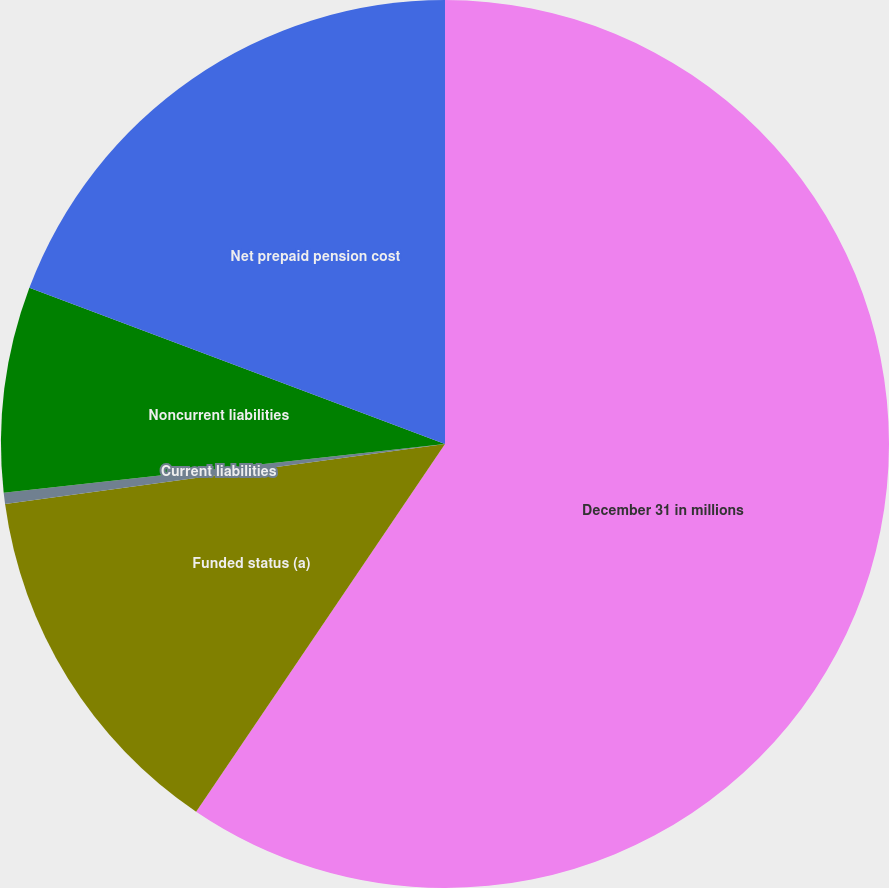<chart> <loc_0><loc_0><loc_500><loc_500><pie_chart><fcel>December 31 in millions<fcel>Funded status (a)<fcel>Current liabilities<fcel>Noncurrent liabilities<fcel>Net prepaid pension cost<nl><fcel>59.47%<fcel>13.37%<fcel>0.41%<fcel>7.47%<fcel>19.28%<nl></chart> 